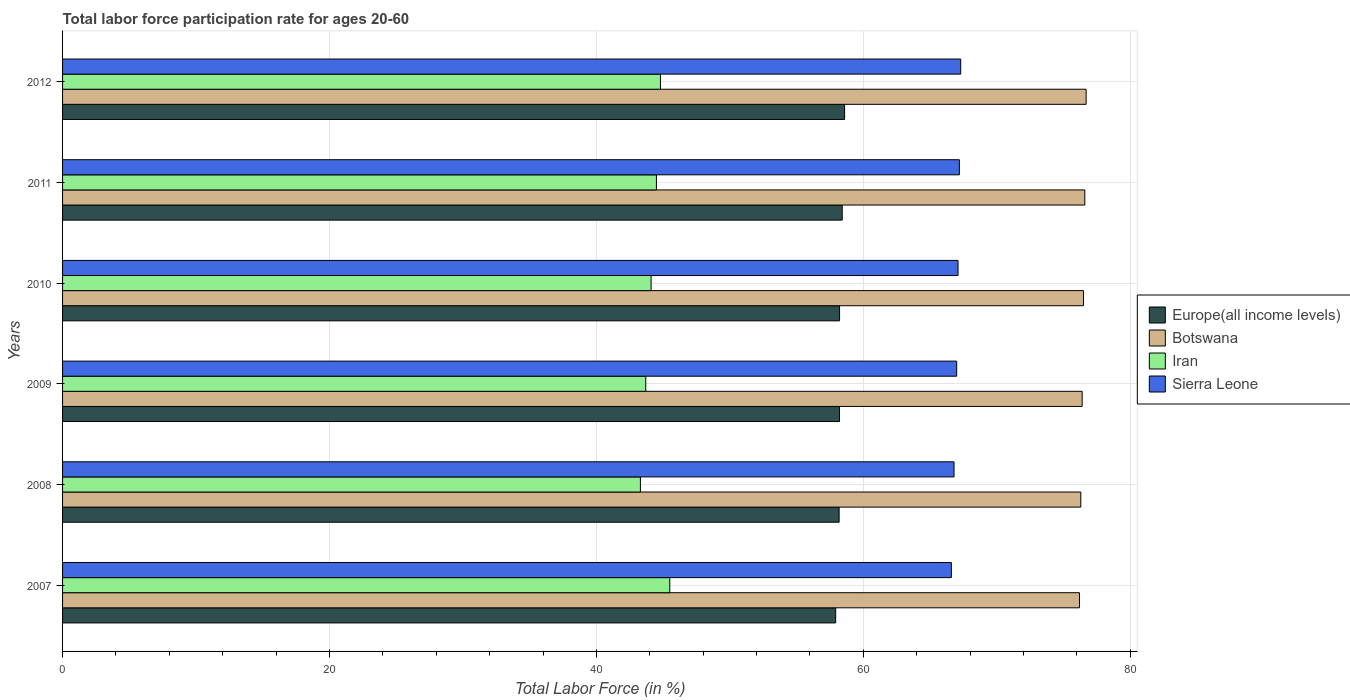Are the number of bars per tick equal to the number of legend labels?
Give a very brief answer. Yes. Are the number of bars on each tick of the Y-axis equal?
Provide a short and direct response. Yes. What is the label of the 5th group of bars from the top?
Make the answer very short. 2008. In how many cases, is the number of bars for a given year not equal to the number of legend labels?
Your answer should be very brief. 0. What is the labor force participation rate in Iran in 2010?
Offer a very short reply. 44.1. Across all years, what is the maximum labor force participation rate in Iran?
Provide a short and direct response. 45.5. Across all years, what is the minimum labor force participation rate in Europe(all income levels)?
Offer a terse response. 57.93. What is the total labor force participation rate in Sierra Leone in the graph?
Offer a very short reply. 402. What is the difference between the labor force participation rate in Botswana in 2008 and that in 2010?
Provide a succinct answer. -0.2. What is the difference between the labor force participation rate in Europe(all income levels) in 2009 and the labor force participation rate in Sierra Leone in 2012?
Make the answer very short. -9.08. What is the average labor force participation rate in Iran per year?
Your answer should be very brief. 44.32. In the year 2008, what is the difference between the labor force participation rate in Europe(all income levels) and labor force participation rate in Botswana?
Your answer should be compact. -18.11. What is the ratio of the labor force participation rate in Europe(all income levels) in 2007 to that in 2010?
Make the answer very short. 0.99. Is the labor force participation rate in Botswana in 2008 less than that in 2012?
Your response must be concise. Yes. Is the difference between the labor force participation rate in Europe(all income levels) in 2009 and 2012 greater than the difference between the labor force participation rate in Botswana in 2009 and 2012?
Offer a very short reply. No. What is the difference between the highest and the second highest labor force participation rate in Sierra Leone?
Your answer should be compact. 0.1. What is the difference between the highest and the lowest labor force participation rate in Europe(all income levels)?
Offer a very short reply. 0.67. What does the 1st bar from the top in 2010 represents?
Provide a succinct answer. Sierra Leone. What does the 3rd bar from the bottom in 2007 represents?
Your answer should be very brief. Iran. Are all the bars in the graph horizontal?
Your answer should be very brief. Yes. Are the values on the major ticks of X-axis written in scientific E-notation?
Give a very brief answer. No. Where does the legend appear in the graph?
Offer a terse response. Center right. How many legend labels are there?
Provide a short and direct response. 4. What is the title of the graph?
Offer a very short reply. Total labor force participation rate for ages 20-60. Does "Denmark" appear as one of the legend labels in the graph?
Provide a succinct answer. No. What is the Total Labor Force (in %) of Europe(all income levels) in 2007?
Offer a terse response. 57.93. What is the Total Labor Force (in %) in Botswana in 2007?
Make the answer very short. 76.2. What is the Total Labor Force (in %) of Iran in 2007?
Offer a terse response. 45.5. What is the Total Labor Force (in %) of Sierra Leone in 2007?
Keep it short and to the point. 66.6. What is the Total Labor Force (in %) of Europe(all income levels) in 2008?
Your answer should be very brief. 58.19. What is the Total Labor Force (in %) in Botswana in 2008?
Your response must be concise. 76.3. What is the Total Labor Force (in %) of Iran in 2008?
Your answer should be very brief. 43.3. What is the Total Labor Force (in %) of Sierra Leone in 2008?
Your answer should be compact. 66.8. What is the Total Labor Force (in %) of Europe(all income levels) in 2009?
Offer a very short reply. 58.22. What is the Total Labor Force (in %) of Botswana in 2009?
Keep it short and to the point. 76.4. What is the Total Labor Force (in %) of Iran in 2009?
Provide a short and direct response. 43.7. What is the Total Labor Force (in %) of Sierra Leone in 2009?
Offer a terse response. 67. What is the Total Labor Force (in %) in Europe(all income levels) in 2010?
Make the answer very short. 58.22. What is the Total Labor Force (in %) of Botswana in 2010?
Your response must be concise. 76.5. What is the Total Labor Force (in %) in Iran in 2010?
Your answer should be compact. 44.1. What is the Total Labor Force (in %) of Sierra Leone in 2010?
Offer a terse response. 67.1. What is the Total Labor Force (in %) in Europe(all income levels) in 2011?
Your response must be concise. 58.42. What is the Total Labor Force (in %) of Botswana in 2011?
Offer a very short reply. 76.6. What is the Total Labor Force (in %) of Iran in 2011?
Provide a succinct answer. 44.5. What is the Total Labor Force (in %) in Sierra Leone in 2011?
Ensure brevity in your answer.  67.2. What is the Total Labor Force (in %) of Europe(all income levels) in 2012?
Ensure brevity in your answer.  58.6. What is the Total Labor Force (in %) in Botswana in 2012?
Your answer should be very brief. 76.7. What is the Total Labor Force (in %) of Iran in 2012?
Offer a very short reply. 44.8. What is the Total Labor Force (in %) of Sierra Leone in 2012?
Your answer should be very brief. 67.3. Across all years, what is the maximum Total Labor Force (in %) of Europe(all income levels)?
Offer a very short reply. 58.6. Across all years, what is the maximum Total Labor Force (in %) of Botswana?
Your response must be concise. 76.7. Across all years, what is the maximum Total Labor Force (in %) in Iran?
Give a very brief answer. 45.5. Across all years, what is the maximum Total Labor Force (in %) of Sierra Leone?
Provide a succinct answer. 67.3. Across all years, what is the minimum Total Labor Force (in %) in Europe(all income levels)?
Give a very brief answer. 57.93. Across all years, what is the minimum Total Labor Force (in %) of Botswana?
Your response must be concise. 76.2. Across all years, what is the minimum Total Labor Force (in %) of Iran?
Give a very brief answer. 43.3. Across all years, what is the minimum Total Labor Force (in %) in Sierra Leone?
Offer a terse response. 66.6. What is the total Total Labor Force (in %) of Europe(all income levels) in the graph?
Make the answer very short. 349.59. What is the total Total Labor Force (in %) of Botswana in the graph?
Provide a short and direct response. 458.7. What is the total Total Labor Force (in %) of Iran in the graph?
Your response must be concise. 265.9. What is the total Total Labor Force (in %) of Sierra Leone in the graph?
Your answer should be compact. 402. What is the difference between the Total Labor Force (in %) of Europe(all income levels) in 2007 and that in 2008?
Make the answer very short. -0.26. What is the difference between the Total Labor Force (in %) in Botswana in 2007 and that in 2008?
Offer a very short reply. -0.1. What is the difference between the Total Labor Force (in %) of Iran in 2007 and that in 2008?
Make the answer very short. 2.2. What is the difference between the Total Labor Force (in %) in Europe(all income levels) in 2007 and that in 2009?
Give a very brief answer. -0.29. What is the difference between the Total Labor Force (in %) of Botswana in 2007 and that in 2009?
Keep it short and to the point. -0.2. What is the difference between the Total Labor Force (in %) in Iran in 2007 and that in 2009?
Your response must be concise. 1.8. What is the difference between the Total Labor Force (in %) of Sierra Leone in 2007 and that in 2009?
Offer a very short reply. -0.4. What is the difference between the Total Labor Force (in %) of Europe(all income levels) in 2007 and that in 2010?
Provide a succinct answer. -0.29. What is the difference between the Total Labor Force (in %) in Iran in 2007 and that in 2010?
Offer a very short reply. 1.4. What is the difference between the Total Labor Force (in %) in Sierra Leone in 2007 and that in 2010?
Offer a terse response. -0.5. What is the difference between the Total Labor Force (in %) in Europe(all income levels) in 2007 and that in 2011?
Provide a succinct answer. -0.49. What is the difference between the Total Labor Force (in %) in Botswana in 2007 and that in 2011?
Your answer should be compact. -0.4. What is the difference between the Total Labor Force (in %) in Iran in 2007 and that in 2011?
Provide a short and direct response. 1. What is the difference between the Total Labor Force (in %) in Sierra Leone in 2007 and that in 2011?
Your answer should be compact. -0.6. What is the difference between the Total Labor Force (in %) in Europe(all income levels) in 2007 and that in 2012?
Your answer should be very brief. -0.67. What is the difference between the Total Labor Force (in %) in Iran in 2007 and that in 2012?
Your answer should be very brief. 0.7. What is the difference between the Total Labor Force (in %) in Sierra Leone in 2007 and that in 2012?
Provide a succinct answer. -0.7. What is the difference between the Total Labor Force (in %) in Europe(all income levels) in 2008 and that in 2009?
Ensure brevity in your answer.  -0.03. What is the difference between the Total Labor Force (in %) of Botswana in 2008 and that in 2009?
Give a very brief answer. -0.1. What is the difference between the Total Labor Force (in %) of Iran in 2008 and that in 2009?
Offer a terse response. -0.4. What is the difference between the Total Labor Force (in %) in Europe(all income levels) in 2008 and that in 2010?
Make the answer very short. -0.03. What is the difference between the Total Labor Force (in %) in Iran in 2008 and that in 2010?
Your response must be concise. -0.8. What is the difference between the Total Labor Force (in %) in Europe(all income levels) in 2008 and that in 2011?
Offer a terse response. -0.23. What is the difference between the Total Labor Force (in %) in Iran in 2008 and that in 2011?
Offer a terse response. -1.2. What is the difference between the Total Labor Force (in %) of Europe(all income levels) in 2008 and that in 2012?
Your answer should be compact. -0.41. What is the difference between the Total Labor Force (in %) of Europe(all income levels) in 2009 and that in 2010?
Your answer should be very brief. -0. What is the difference between the Total Labor Force (in %) of Botswana in 2009 and that in 2010?
Provide a succinct answer. -0.1. What is the difference between the Total Labor Force (in %) in Sierra Leone in 2009 and that in 2010?
Your answer should be very brief. -0.1. What is the difference between the Total Labor Force (in %) in Europe(all income levels) in 2009 and that in 2011?
Provide a succinct answer. -0.2. What is the difference between the Total Labor Force (in %) in Botswana in 2009 and that in 2011?
Your answer should be compact. -0.2. What is the difference between the Total Labor Force (in %) of Iran in 2009 and that in 2011?
Your answer should be compact. -0.8. What is the difference between the Total Labor Force (in %) of Sierra Leone in 2009 and that in 2011?
Offer a very short reply. -0.2. What is the difference between the Total Labor Force (in %) in Europe(all income levels) in 2009 and that in 2012?
Give a very brief answer. -0.38. What is the difference between the Total Labor Force (in %) of Iran in 2009 and that in 2012?
Your answer should be very brief. -1.1. What is the difference between the Total Labor Force (in %) in Europe(all income levels) in 2010 and that in 2011?
Provide a succinct answer. -0.2. What is the difference between the Total Labor Force (in %) in Botswana in 2010 and that in 2011?
Keep it short and to the point. -0.1. What is the difference between the Total Labor Force (in %) of Iran in 2010 and that in 2011?
Ensure brevity in your answer.  -0.4. What is the difference between the Total Labor Force (in %) of Europe(all income levels) in 2010 and that in 2012?
Your answer should be compact. -0.38. What is the difference between the Total Labor Force (in %) of Iran in 2010 and that in 2012?
Give a very brief answer. -0.7. What is the difference between the Total Labor Force (in %) of Sierra Leone in 2010 and that in 2012?
Provide a short and direct response. -0.2. What is the difference between the Total Labor Force (in %) in Europe(all income levels) in 2011 and that in 2012?
Provide a succinct answer. -0.18. What is the difference between the Total Labor Force (in %) in Iran in 2011 and that in 2012?
Your answer should be very brief. -0.3. What is the difference between the Total Labor Force (in %) of Sierra Leone in 2011 and that in 2012?
Your response must be concise. -0.1. What is the difference between the Total Labor Force (in %) of Europe(all income levels) in 2007 and the Total Labor Force (in %) of Botswana in 2008?
Keep it short and to the point. -18.37. What is the difference between the Total Labor Force (in %) in Europe(all income levels) in 2007 and the Total Labor Force (in %) in Iran in 2008?
Give a very brief answer. 14.63. What is the difference between the Total Labor Force (in %) in Europe(all income levels) in 2007 and the Total Labor Force (in %) in Sierra Leone in 2008?
Provide a short and direct response. -8.87. What is the difference between the Total Labor Force (in %) in Botswana in 2007 and the Total Labor Force (in %) in Iran in 2008?
Your answer should be very brief. 32.9. What is the difference between the Total Labor Force (in %) of Iran in 2007 and the Total Labor Force (in %) of Sierra Leone in 2008?
Your answer should be very brief. -21.3. What is the difference between the Total Labor Force (in %) in Europe(all income levels) in 2007 and the Total Labor Force (in %) in Botswana in 2009?
Your answer should be compact. -18.47. What is the difference between the Total Labor Force (in %) in Europe(all income levels) in 2007 and the Total Labor Force (in %) in Iran in 2009?
Keep it short and to the point. 14.23. What is the difference between the Total Labor Force (in %) in Europe(all income levels) in 2007 and the Total Labor Force (in %) in Sierra Leone in 2009?
Provide a succinct answer. -9.07. What is the difference between the Total Labor Force (in %) of Botswana in 2007 and the Total Labor Force (in %) of Iran in 2009?
Your answer should be very brief. 32.5. What is the difference between the Total Labor Force (in %) of Botswana in 2007 and the Total Labor Force (in %) of Sierra Leone in 2009?
Your response must be concise. 9.2. What is the difference between the Total Labor Force (in %) of Iran in 2007 and the Total Labor Force (in %) of Sierra Leone in 2009?
Keep it short and to the point. -21.5. What is the difference between the Total Labor Force (in %) of Europe(all income levels) in 2007 and the Total Labor Force (in %) of Botswana in 2010?
Keep it short and to the point. -18.57. What is the difference between the Total Labor Force (in %) of Europe(all income levels) in 2007 and the Total Labor Force (in %) of Iran in 2010?
Make the answer very short. 13.83. What is the difference between the Total Labor Force (in %) of Europe(all income levels) in 2007 and the Total Labor Force (in %) of Sierra Leone in 2010?
Provide a short and direct response. -9.17. What is the difference between the Total Labor Force (in %) in Botswana in 2007 and the Total Labor Force (in %) in Iran in 2010?
Provide a succinct answer. 32.1. What is the difference between the Total Labor Force (in %) in Iran in 2007 and the Total Labor Force (in %) in Sierra Leone in 2010?
Your answer should be very brief. -21.6. What is the difference between the Total Labor Force (in %) of Europe(all income levels) in 2007 and the Total Labor Force (in %) of Botswana in 2011?
Ensure brevity in your answer.  -18.67. What is the difference between the Total Labor Force (in %) in Europe(all income levels) in 2007 and the Total Labor Force (in %) in Iran in 2011?
Make the answer very short. 13.43. What is the difference between the Total Labor Force (in %) in Europe(all income levels) in 2007 and the Total Labor Force (in %) in Sierra Leone in 2011?
Provide a short and direct response. -9.27. What is the difference between the Total Labor Force (in %) of Botswana in 2007 and the Total Labor Force (in %) of Iran in 2011?
Provide a succinct answer. 31.7. What is the difference between the Total Labor Force (in %) in Botswana in 2007 and the Total Labor Force (in %) in Sierra Leone in 2011?
Your answer should be very brief. 9. What is the difference between the Total Labor Force (in %) of Iran in 2007 and the Total Labor Force (in %) of Sierra Leone in 2011?
Make the answer very short. -21.7. What is the difference between the Total Labor Force (in %) of Europe(all income levels) in 2007 and the Total Labor Force (in %) of Botswana in 2012?
Your answer should be compact. -18.77. What is the difference between the Total Labor Force (in %) in Europe(all income levels) in 2007 and the Total Labor Force (in %) in Iran in 2012?
Give a very brief answer. 13.13. What is the difference between the Total Labor Force (in %) in Europe(all income levels) in 2007 and the Total Labor Force (in %) in Sierra Leone in 2012?
Make the answer very short. -9.37. What is the difference between the Total Labor Force (in %) in Botswana in 2007 and the Total Labor Force (in %) in Iran in 2012?
Give a very brief answer. 31.4. What is the difference between the Total Labor Force (in %) in Botswana in 2007 and the Total Labor Force (in %) in Sierra Leone in 2012?
Provide a short and direct response. 8.9. What is the difference between the Total Labor Force (in %) in Iran in 2007 and the Total Labor Force (in %) in Sierra Leone in 2012?
Keep it short and to the point. -21.8. What is the difference between the Total Labor Force (in %) in Europe(all income levels) in 2008 and the Total Labor Force (in %) in Botswana in 2009?
Ensure brevity in your answer.  -18.21. What is the difference between the Total Labor Force (in %) in Europe(all income levels) in 2008 and the Total Labor Force (in %) in Iran in 2009?
Ensure brevity in your answer.  14.49. What is the difference between the Total Labor Force (in %) in Europe(all income levels) in 2008 and the Total Labor Force (in %) in Sierra Leone in 2009?
Your answer should be compact. -8.81. What is the difference between the Total Labor Force (in %) in Botswana in 2008 and the Total Labor Force (in %) in Iran in 2009?
Offer a very short reply. 32.6. What is the difference between the Total Labor Force (in %) in Iran in 2008 and the Total Labor Force (in %) in Sierra Leone in 2009?
Make the answer very short. -23.7. What is the difference between the Total Labor Force (in %) in Europe(all income levels) in 2008 and the Total Labor Force (in %) in Botswana in 2010?
Make the answer very short. -18.31. What is the difference between the Total Labor Force (in %) in Europe(all income levels) in 2008 and the Total Labor Force (in %) in Iran in 2010?
Your answer should be compact. 14.09. What is the difference between the Total Labor Force (in %) in Europe(all income levels) in 2008 and the Total Labor Force (in %) in Sierra Leone in 2010?
Keep it short and to the point. -8.91. What is the difference between the Total Labor Force (in %) of Botswana in 2008 and the Total Labor Force (in %) of Iran in 2010?
Offer a terse response. 32.2. What is the difference between the Total Labor Force (in %) in Botswana in 2008 and the Total Labor Force (in %) in Sierra Leone in 2010?
Offer a terse response. 9.2. What is the difference between the Total Labor Force (in %) of Iran in 2008 and the Total Labor Force (in %) of Sierra Leone in 2010?
Your answer should be compact. -23.8. What is the difference between the Total Labor Force (in %) in Europe(all income levels) in 2008 and the Total Labor Force (in %) in Botswana in 2011?
Your answer should be very brief. -18.41. What is the difference between the Total Labor Force (in %) in Europe(all income levels) in 2008 and the Total Labor Force (in %) in Iran in 2011?
Your answer should be very brief. 13.69. What is the difference between the Total Labor Force (in %) in Europe(all income levels) in 2008 and the Total Labor Force (in %) in Sierra Leone in 2011?
Provide a short and direct response. -9.01. What is the difference between the Total Labor Force (in %) in Botswana in 2008 and the Total Labor Force (in %) in Iran in 2011?
Offer a very short reply. 31.8. What is the difference between the Total Labor Force (in %) in Botswana in 2008 and the Total Labor Force (in %) in Sierra Leone in 2011?
Your answer should be compact. 9.1. What is the difference between the Total Labor Force (in %) of Iran in 2008 and the Total Labor Force (in %) of Sierra Leone in 2011?
Your answer should be compact. -23.9. What is the difference between the Total Labor Force (in %) in Europe(all income levels) in 2008 and the Total Labor Force (in %) in Botswana in 2012?
Your answer should be very brief. -18.51. What is the difference between the Total Labor Force (in %) in Europe(all income levels) in 2008 and the Total Labor Force (in %) in Iran in 2012?
Your answer should be compact. 13.39. What is the difference between the Total Labor Force (in %) of Europe(all income levels) in 2008 and the Total Labor Force (in %) of Sierra Leone in 2012?
Ensure brevity in your answer.  -9.11. What is the difference between the Total Labor Force (in %) in Botswana in 2008 and the Total Labor Force (in %) in Iran in 2012?
Offer a very short reply. 31.5. What is the difference between the Total Labor Force (in %) in Botswana in 2008 and the Total Labor Force (in %) in Sierra Leone in 2012?
Provide a short and direct response. 9. What is the difference between the Total Labor Force (in %) of Iran in 2008 and the Total Labor Force (in %) of Sierra Leone in 2012?
Your answer should be very brief. -24. What is the difference between the Total Labor Force (in %) of Europe(all income levels) in 2009 and the Total Labor Force (in %) of Botswana in 2010?
Keep it short and to the point. -18.28. What is the difference between the Total Labor Force (in %) of Europe(all income levels) in 2009 and the Total Labor Force (in %) of Iran in 2010?
Your response must be concise. 14.12. What is the difference between the Total Labor Force (in %) in Europe(all income levels) in 2009 and the Total Labor Force (in %) in Sierra Leone in 2010?
Your answer should be very brief. -8.88. What is the difference between the Total Labor Force (in %) in Botswana in 2009 and the Total Labor Force (in %) in Iran in 2010?
Ensure brevity in your answer.  32.3. What is the difference between the Total Labor Force (in %) of Botswana in 2009 and the Total Labor Force (in %) of Sierra Leone in 2010?
Provide a short and direct response. 9.3. What is the difference between the Total Labor Force (in %) of Iran in 2009 and the Total Labor Force (in %) of Sierra Leone in 2010?
Your response must be concise. -23.4. What is the difference between the Total Labor Force (in %) of Europe(all income levels) in 2009 and the Total Labor Force (in %) of Botswana in 2011?
Ensure brevity in your answer.  -18.38. What is the difference between the Total Labor Force (in %) of Europe(all income levels) in 2009 and the Total Labor Force (in %) of Iran in 2011?
Give a very brief answer. 13.72. What is the difference between the Total Labor Force (in %) in Europe(all income levels) in 2009 and the Total Labor Force (in %) in Sierra Leone in 2011?
Your answer should be compact. -8.98. What is the difference between the Total Labor Force (in %) in Botswana in 2009 and the Total Labor Force (in %) in Iran in 2011?
Your answer should be very brief. 31.9. What is the difference between the Total Labor Force (in %) of Botswana in 2009 and the Total Labor Force (in %) of Sierra Leone in 2011?
Make the answer very short. 9.2. What is the difference between the Total Labor Force (in %) in Iran in 2009 and the Total Labor Force (in %) in Sierra Leone in 2011?
Your response must be concise. -23.5. What is the difference between the Total Labor Force (in %) in Europe(all income levels) in 2009 and the Total Labor Force (in %) in Botswana in 2012?
Offer a very short reply. -18.48. What is the difference between the Total Labor Force (in %) of Europe(all income levels) in 2009 and the Total Labor Force (in %) of Iran in 2012?
Offer a very short reply. 13.42. What is the difference between the Total Labor Force (in %) of Europe(all income levels) in 2009 and the Total Labor Force (in %) of Sierra Leone in 2012?
Give a very brief answer. -9.08. What is the difference between the Total Labor Force (in %) of Botswana in 2009 and the Total Labor Force (in %) of Iran in 2012?
Your answer should be compact. 31.6. What is the difference between the Total Labor Force (in %) in Botswana in 2009 and the Total Labor Force (in %) in Sierra Leone in 2012?
Your answer should be very brief. 9.1. What is the difference between the Total Labor Force (in %) in Iran in 2009 and the Total Labor Force (in %) in Sierra Leone in 2012?
Keep it short and to the point. -23.6. What is the difference between the Total Labor Force (in %) of Europe(all income levels) in 2010 and the Total Labor Force (in %) of Botswana in 2011?
Provide a succinct answer. -18.38. What is the difference between the Total Labor Force (in %) of Europe(all income levels) in 2010 and the Total Labor Force (in %) of Iran in 2011?
Keep it short and to the point. 13.72. What is the difference between the Total Labor Force (in %) in Europe(all income levels) in 2010 and the Total Labor Force (in %) in Sierra Leone in 2011?
Offer a terse response. -8.98. What is the difference between the Total Labor Force (in %) of Botswana in 2010 and the Total Labor Force (in %) of Iran in 2011?
Keep it short and to the point. 32. What is the difference between the Total Labor Force (in %) of Botswana in 2010 and the Total Labor Force (in %) of Sierra Leone in 2011?
Keep it short and to the point. 9.3. What is the difference between the Total Labor Force (in %) in Iran in 2010 and the Total Labor Force (in %) in Sierra Leone in 2011?
Offer a very short reply. -23.1. What is the difference between the Total Labor Force (in %) of Europe(all income levels) in 2010 and the Total Labor Force (in %) of Botswana in 2012?
Make the answer very short. -18.48. What is the difference between the Total Labor Force (in %) of Europe(all income levels) in 2010 and the Total Labor Force (in %) of Iran in 2012?
Provide a short and direct response. 13.42. What is the difference between the Total Labor Force (in %) of Europe(all income levels) in 2010 and the Total Labor Force (in %) of Sierra Leone in 2012?
Your response must be concise. -9.08. What is the difference between the Total Labor Force (in %) in Botswana in 2010 and the Total Labor Force (in %) in Iran in 2012?
Provide a short and direct response. 31.7. What is the difference between the Total Labor Force (in %) in Botswana in 2010 and the Total Labor Force (in %) in Sierra Leone in 2012?
Offer a terse response. 9.2. What is the difference between the Total Labor Force (in %) in Iran in 2010 and the Total Labor Force (in %) in Sierra Leone in 2012?
Keep it short and to the point. -23.2. What is the difference between the Total Labor Force (in %) of Europe(all income levels) in 2011 and the Total Labor Force (in %) of Botswana in 2012?
Provide a short and direct response. -18.28. What is the difference between the Total Labor Force (in %) in Europe(all income levels) in 2011 and the Total Labor Force (in %) in Iran in 2012?
Make the answer very short. 13.62. What is the difference between the Total Labor Force (in %) of Europe(all income levels) in 2011 and the Total Labor Force (in %) of Sierra Leone in 2012?
Make the answer very short. -8.88. What is the difference between the Total Labor Force (in %) of Botswana in 2011 and the Total Labor Force (in %) of Iran in 2012?
Ensure brevity in your answer.  31.8. What is the difference between the Total Labor Force (in %) in Iran in 2011 and the Total Labor Force (in %) in Sierra Leone in 2012?
Offer a terse response. -22.8. What is the average Total Labor Force (in %) in Europe(all income levels) per year?
Your answer should be compact. 58.26. What is the average Total Labor Force (in %) in Botswana per year?
Provide a succinct answer. 76.45. What is the average Total Labor Force (in %) in Iran per year?
Keep it short and to the point. 44.32. In the year 2007, what is the difference between the Total Labor Force (in %) in Europe(all income levels) and Total Labor Force (in %) in Botswana?
Make the answer very short. -18.27. In the year 2007, what is the difference between the Total Labor Force (in %) of Europe(all income levels) and Total Labor Force (in %) of Iran?
Give a very brief answer. 12.43. In the year 2007, what is the difference between the Total Labor Force (in %) of Europe(all income levels) and Total Labor Force (in %) of Sierra Leone?
Offer a very short reply. -8.67. In the year 2007, what is the difference between the Total Labor Force (in %) of Botswana and Total Labor Force (in %) of Iran?
Offer a very short reply. 30.7. In the year 2007, what is the difference between the Total Labor Force (in %) of Iran and Total Labor Force (in %) of Sierra Leone?
Make the answer very short. -21.1. In the year 2008, what is the difference between the Total Labor Force (in %) in Europe(all income levels) and Total Labor Force (in %) in Botswana?
Your response must be concise. -18.11. In the year 2008, what is the difference between the Total Labor Force (in %) of Europe(all income levels) and Total Labor Force (in %) of Iran?
Offer a very short reply. 14.89. In the year 2008, what is the difference between the Total Labor Force (in %) of Europe(all income levels) and Total Labor Force (in %) of Sierra Leone?
Ensure brevity in your answer.  -8.61. In the year 2008, what is the difference between the Total Labor Force (in %) in Botswana and Total Labor Force (in %) in Iran?
Ensure brevity in your answer.  33. In the year 2008, what is the difference between the Total Labor Force (in %) in Iran and Total Labor Force (in %) in Sierra Leone?
Offer a very short reply. -23.5. In the year 2009, what is the difference between the Total Labor Force (in %) of Europe(all income levels) and Total Labor Force (in %) of Botswana?
Provide a succinct answer. -18.18. In the year 2009, what is the difference between the Total Labor Force (in %) in Europe(all income levels) and Total Labor Force (in %) in Iran?
Your answer should be compact. 14.52. In the year 2009, what is the difference between the Total Labor Force (in %) of Europe(all income levels) and Total Labor Force (in %) of Sierra Leone?
Offer a very short reply. -8.78. In the year 2009, what is the difference between the Total Labor Force (in %) of Botswana and Total Labor Force (in %) of Iran?
Ensure brevity in your answer.  32.7. In the year 2009, what is the difference between the Total Labor Force (in %) of Botswana and Total Labor Force (in %) of Sierra Leone?
Offer a very short reply. 9.4. In the year 2009, what is the difference between the Total Labor Force (in %) of Iran and Total Labor Force (in %) of Sierra Leone?
Make the answer very short. -23.3. In the year 2010, what is the difference between the Total Labor Force (in %) in Europe(all income levels) and Total Labor Force (in %) in Botswana?
Provide a short and direct response. -18.28. In the year 2010, what is the difference between the Total Labor Force (in %) in Europe(all income levels) and Total Labor Force (in %) in Iran?
Keep it short and to the point. 14.12. In the year 2010, what is the difference between the Total Labor Force (in %) in Europe(all income levels) and Total Labor Force (in %) in Sierra Leone?
Your response must be concise. -8.88. In the year 2010, what is the difference between the Total Labor Force (in %) of Botswana and Total Labor Force (in %) of Iran?
Give a very brief answer. 32.4. In the year 2010, what is the difference between the Total Labor Force (in %) of Iran and Total Labor Force (in %) of Sierra Leone?
Your answer should be compact. -23. In the year 2011, what is the difference between the Total Labor Force (in %) in Europe(all income levels) and Total Labor Force (in %) in Botswana?
Offer a terse response. -18.18. In the year 2011, what is the difference between the Total Labor Force (in %) of Europe(all income levels) and Total Labor Force (in %) of Iran?
Give a very brief answer. 13.92. In the year 2011, what is the difference between the Total Labor Force (in %) of Europe(all income levels) and Total Labor Force (in %) of Sierra Leone?
Keep it short and to the point. -8.78. In the year 2011, what is the difference between the Total Labor Force (in %) of Botswana and Total Labor Force (in %) of Iran?
Keep it short and to the point. 32.1. In the year 2011, what is the difference between the Total Labor Force (in %) in Iran and Total Labor Force (in %) in Sierra Leone?
Provide a short and direct response. -22.7. In the year 2012, what is the difference between the Total Labor Force (in %) in Europe(all income levels) and Total Labor Force (in %) in Botswana?
Give a very brief answer. -18.1. In the year 2012, what is the difference between the Total Labor Force (in %) of Europe(all income levels) and Total Labor Force (in %) of Iran?
Offer a very short reply. 13.8. In the year 2012, what is the difference between the Total Labor Force (in %) of Europe(all income levels) and Total Labor Force (in %) of Sierra Leone?
Your answer should be compact. -8.7. In the year 2012, what is the difference between the Total Labor Force (in %) of Botswana and Total Labor Force (in %) of Iran?
Provide a succinct answer. 31.9. In the year 2012, what is the difference between the Total Labor Force (in %) of Botswana and Total Labor Force (in %) of Sierra Leone?
Your response must be concise. 9.4. In the year 2012, what is the difference between the Total Labor Force (in %) in Iran and Total Labor Force (in %) in Sierra Leone?
Ensure brevity in your answer.  -22.5. What is the ratio of the Total Labor Force (in %) of Europe(all income levels) in 2007 to that in 2008?
Ensure brevity in your answer.  1. What is the ratio of the Total Labor Force (in %) of Botswana in 2007 to that in 2008?
Offer a very short reply. 1. What is the ratio of the Total Labor Force (in %) of Iran in 2007 to that in 2008?
Provide a short and direct response. 1.05. What is the ratio of the Total Labor Force (in %) in Sierra Leone in 2007 to that in 2008?
Your response must be concise. 1. What is the ratio of the Total Labor Force (in %) of Europe(all income levels) in 2007 to that in 2009?
Give a very brief answer. 1. What is the ratio of the Total Labor Force (in %) of Botswana in 2007 to that in 2009?
Make the answer very short. 1. What is the ratio of the Total Labor Force (in %) in Iran in 2007 to that in 2009?
Your answer should be compact. 1.04. What is the ratio of the Total Labor Force (in %) of Europe(all income levels) in 2007 to that in 2010?
Your answer should be compact. 0.99. What is the ratio of the Total Labor Force (in %) in Iran in 2007 to that in 2010?
Provide a succinct answer. 1.03. What is the ratio of the Total Labor Force (in %) of Europe(all income levels) in 2007 to that in 2011?
Make the answer very short. 0.99. What is the ratio of the Total Labor Force (in %) of Botswana in 2007 to that in 2011?
Keep it short and to the point. 0.99. What is the ratio of the Total Labor Force (in %) of Iran in 2007 to that in 2011?
Your answer should be very brief. 1.02. What is the ratio of the Total Labor Force (in %) in Sierra Leone in 2007 to that in 2011?
Your answer should be very brief. 0.99. What is the ratio of the Total Labor Force (in %) of Botswana in 2007 to that in 2012?
Your response must be concise. 0.99. What is the ratio of the Total Labor Force (in %) of Iran in 2007 to that in 2012?
Your answer should be very brief. 1.02. What is the ratio of the Total Labor Force (in %) of Sierra Leone in 2007 to that in 2012?
Give a very brief answer. 0.99. What is the ratio of the Total Labor Force (in %) of Iran in 2008 to that in 2009?
Keep it short and to the point. 0.99. What is the ratio of the Total Labor Force (in %) of Iran in 2008 to that in 2010?
Give a very brief answer. 0.98. What is the ratio of the Total Labor Force (in %) in Sierra Leone in 2008 to that in 2010?
Offer a terse response. 1. What is the ratio of the Total Labor Force (in %) in Botswana in 2008 to that in 2011?
Offer a very short reply. 1. What is the ratio of the Total Labor Force (in %) of Sierra Leone in 2008 to that in 2011?
Provide a succinct answer. 0.99. What is the ratio of the Total Labor Force (in %) in Europe(all income levels) in 2008 to that in 2012?
Offer a terse response. 0.99. What is the ratio of the Total Labor Force (in %) in Iran in 2008 to that in 2012?
Ensure brevity in your answer.  0.97. What is the ratio of the Total Labor Force (in %) of Sierra Leone in 2008 to that in 2012?
Your answer should be compact. 0.99. What is the ratio of the Total Labor Force (in %) of Iran in 2009 to that in 2010?
Provide a short and direct response. 0.99. What is the ratio of the Total Labor Force (in %) of Botswana in 2009 to that in 2011?
Give a very brief answer. 1. What is the ratio of the Total Labor Force (in %) in Europe(all income levels) in 2009 to that in 2012?
Your response must be concise. 0.99. What is the ratio of the Total Labor Force (in %) of Botswana in 2009 to that in 2012?
Offer a terse response. 1. What is the ratio of the Total Labor Force (in %) of Iran in 2009 to that in 2012?
Give a very brief answer. 0.98. What is the ratio of the Total Labor Force (in %) of Sierra Leone in 2009 to that in 2012?
Give a very brief answer. 1. What is the ratio of the Total Labor Force (in %) in Botswana in 2010 to that in 2011?
Your response must be concise. 1. What is the ratio of the Total Labor Force (in %) of Iran in 2010 to that in 2011?
Your answer should be compact. 0.99. What is the ratio of the Total Labor Force (in %) in Sierra Leone in 2010 to that in 2011?
Your answer should be compact. 1. What is the ratio of the Total Labor Force (in %) of Botswana in 2010 to that in 2012?
Make the answer very short. 1. What is the ratio of the Total Labor Force (in %) in Iran in 2010 to that in 2012?
Keep it short and to the point. 0.98. What is the ratio of the Total Labor Force (in %) of Sierra Leone in 2010 to that in 2012?
Your answer should be very brief. 1. What is the ratio of the Total Labor Force (in %) of Iran in 2011 to that in 2012?
Your answer should be very brief. 0.99. What is the difference between the highest and the second highest Total Labor Force (in %) of Europe(all income levels)?
Your answer should be very brief. 0.18. What is the difference between the highest and the second highest Total Labor Force (in %) in Iran?
Your answer should be compact. 0.7. What is the difference between the highest and the lowest Total Labor Force (in %) of Europe(all income levels)?
Keep it short and to the point. 0.67. What is the difference between the highest and the lowest Total Labor Force (in %) of Botswana?
Your response must be concise. 0.5. What is the difference between the highest and the lowest Total Labor Force (in %) of Iran?
Provide a short and direct response. 2.2. 